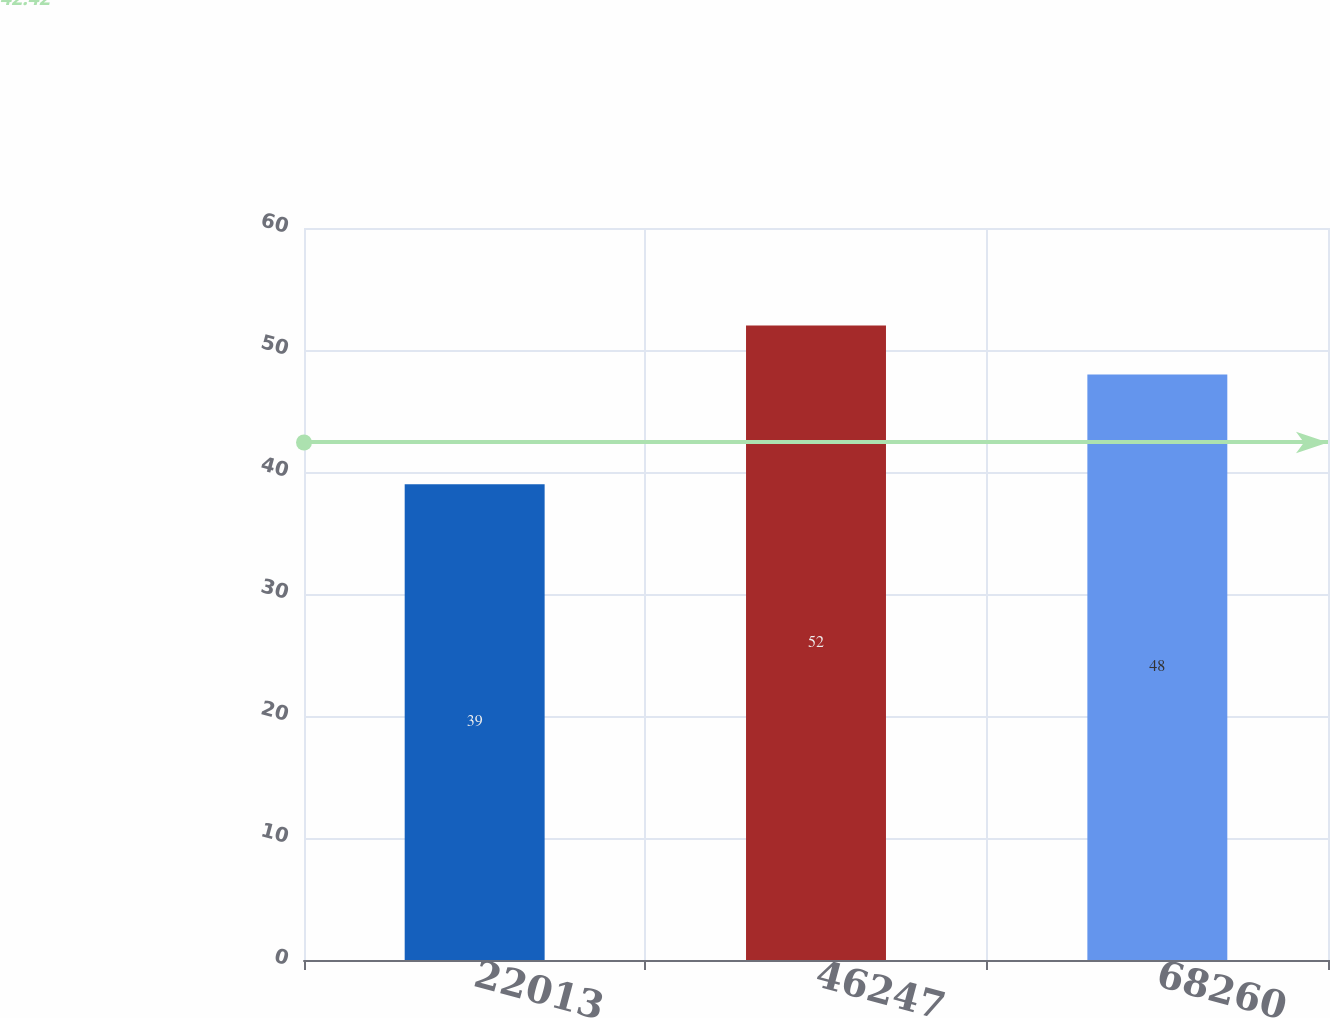<chart> <loc_0><loc_0><loc_500><loc_500><bar_chart><fcel>22013<fcel>46247<fcel>68260<nl><fcel>39<fcel>52<fcel>48<nl></chart> 